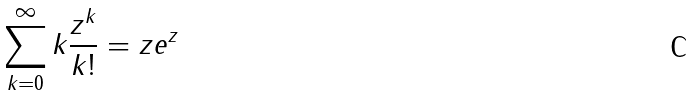Convert formula to latex. <formula><loc_0><loc_0><loc_500><loc_500>\sum _ { k = 0 } ^ { \infty } k \frac { z ^ { k } } { k ! } = z e ^ { z }</formula> 